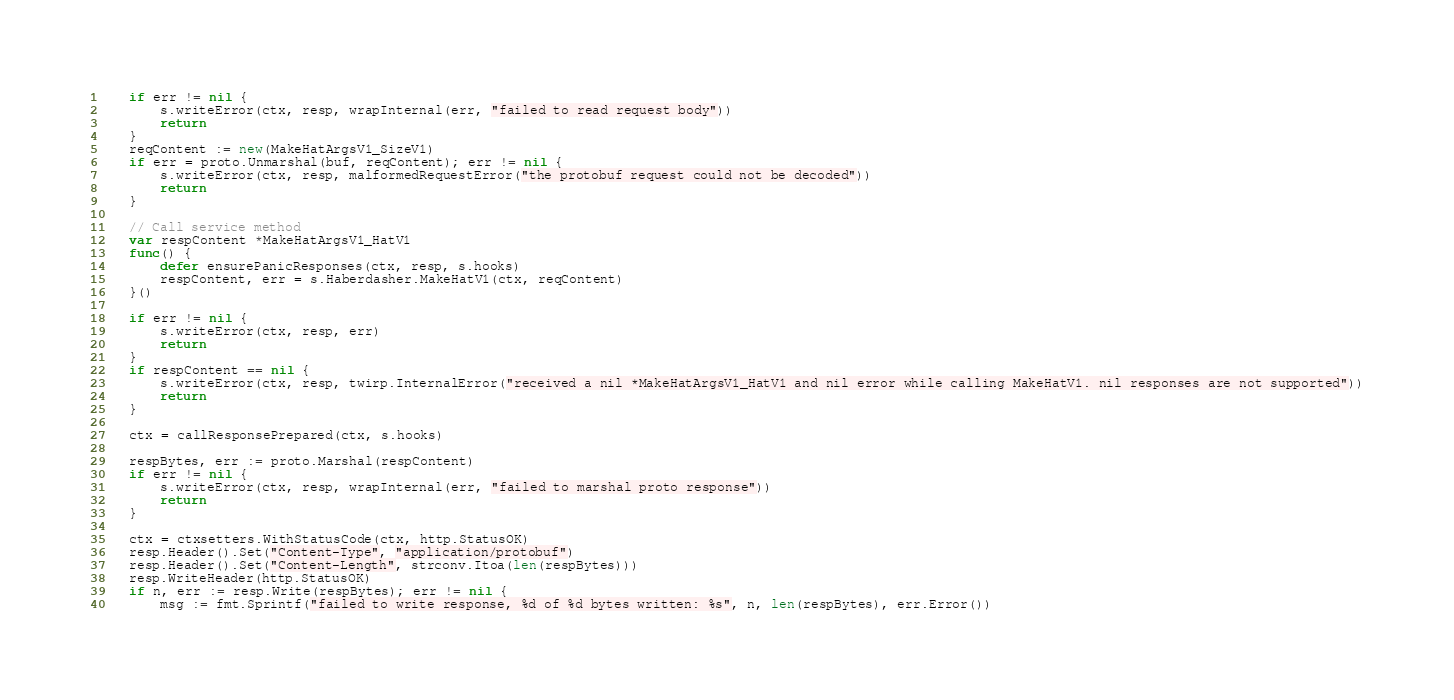<code> <loc_0><loc_0><loc_500><loc_500><_Go_>	if err != nil {
		s.writeError(ctx, resp, wrapInternal(err, "failed to read request body"))
		return
	}
	reqContent := new(MakeHatArgsV1_SizeV1)
	if err = proto.Unmarshal(buf, reqContent); err != nil {
		s.writeError(ctx, resp, malformedRequestError("the protobuf request could not be decoded"))
		return
	}

	// Call service method
	var respContent *MakeHatArgsV1_HatV1
	func() {
		defer ensurePanicResponses(ctx, resp, s.hooks)
		respContent, err = s.Haberdasher.MakeHatV1(ctx, reqContent)
	}()

	if err != nil {
		s.writeError(ctx, resp, err)
		return
	}
	if respContent == nil {
		s.writeError(ctx, resp, twirp.InternalError("received a nil *MakeHatArgsV1_HatV1 and nil error while calling MakeHatV1. nil responses are not supported"))
		return
	}

	ctx = callResponsePrepared(ctx, s.hooks)

	respBytes, err := proto.Marshal(respContent)
	if err != nil {
		s.writeError(ctx, resp, wrapInternal(err, "failed to marshal proto response"))
		return
	}

	ctx = ctxsetters.WithStatusCode(ctx, http.StatusOK)
	resp.Header().Set("Content-Type", "application/protobuf")
	resp.Header().Set("Content-Length", strconv.Itoa(len(respBytes)))
	resp.WriteHeader(http.StatusOK)
	if n, err := resp.Write(respBytes); err != nil {
		msg := fmt.Sprintf("failed to write response, %d of %d bytes written: %s", n, len(respBytes), err.Error())</code> 